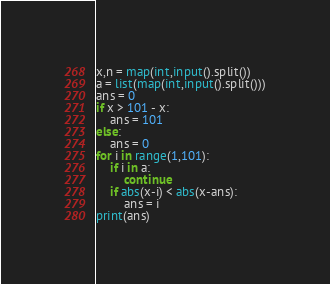Convert code to text. <code><loc_0><loc_0><loc_500><loc_500><_Python_>x,n = map(int,input().split())
a = list(map(int,input().split()))
ans = 0
if x > 101 - x:
    ans = 101
else:
    ans = 0
for i in range(1,101):
    if i in a:
        continue
    if abs(x-i) < abs(x-ans):
        ans = i
print(ans)</code> 